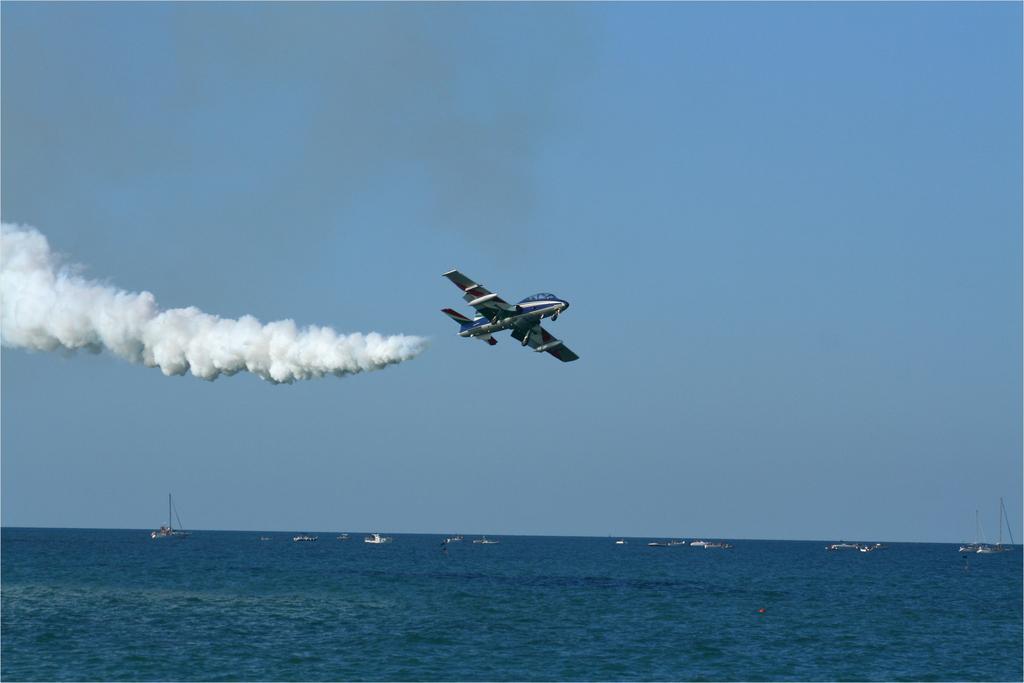In one or two sentences, can you explain what this image depicts? In this picture I can see the water in front and I can see few boats on the water and in the background I can see the sky. In the middle of this picture I can see an aircraft and behind it, I can see the smoke. 